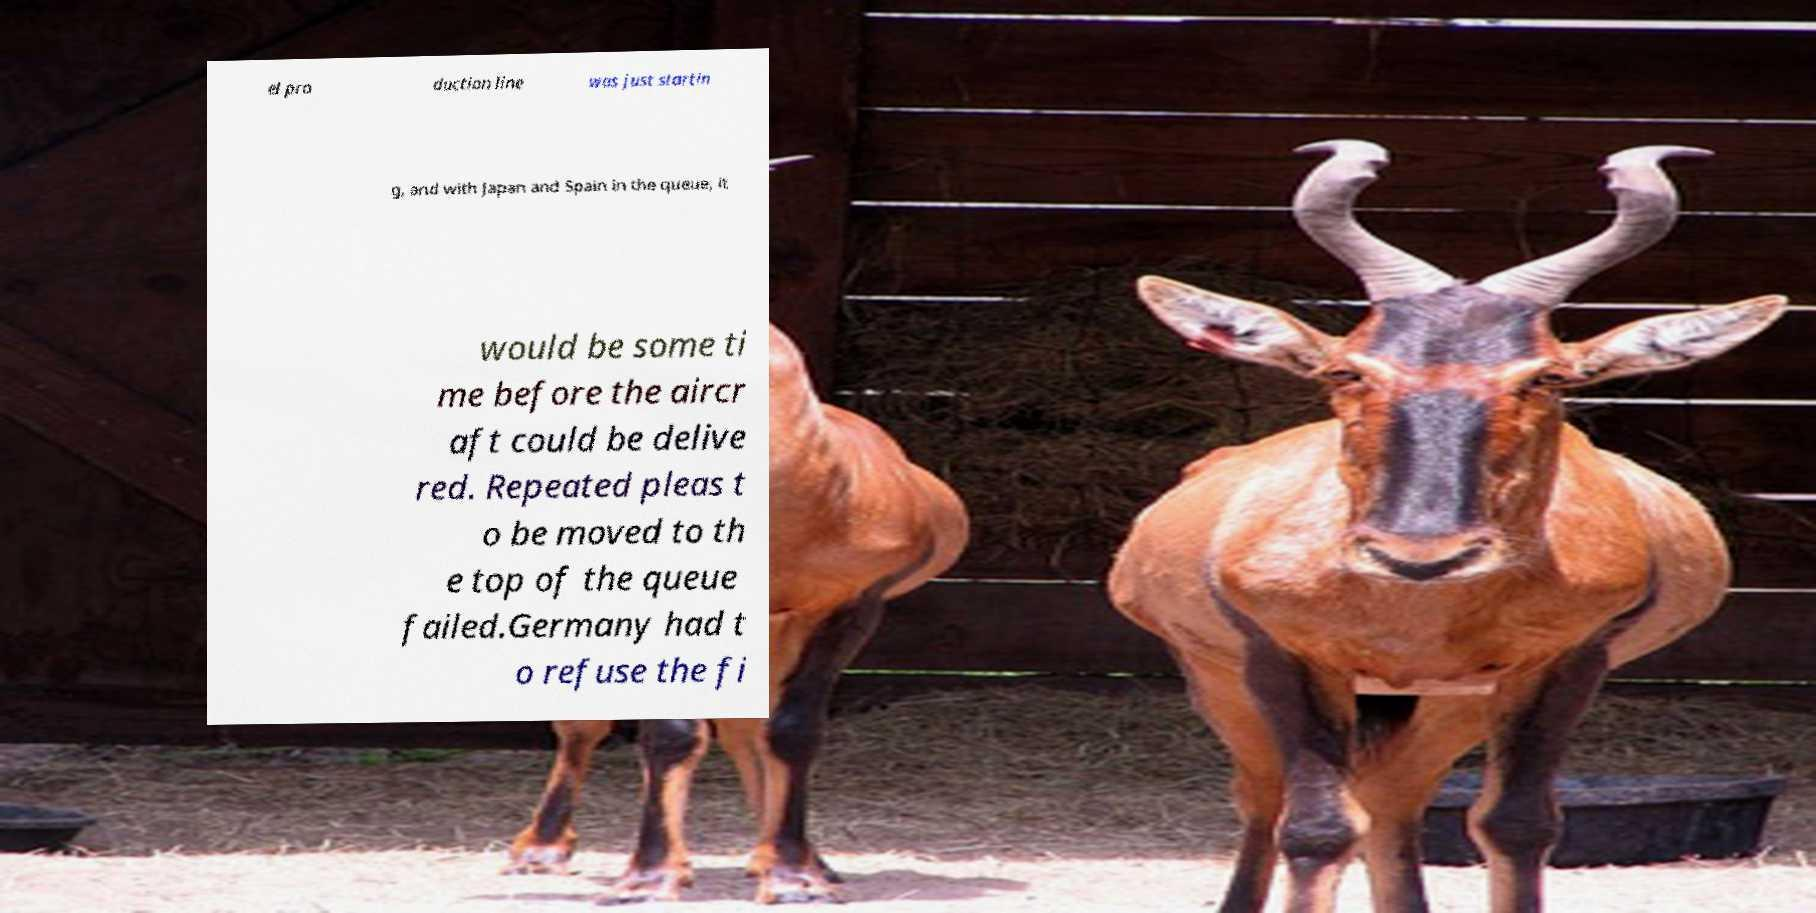Can you read and provide the text displayed in the image?This photo seems to have some interesting text. Can you extract and type it out for me? el pro duction line was just startin g, and with Japan and Spain in the queue, it would be some ti me before the aircr aft could be delive red. Repeated pleas t o be moved to th e top of the queue failed.Germany had t o refuse the fi 